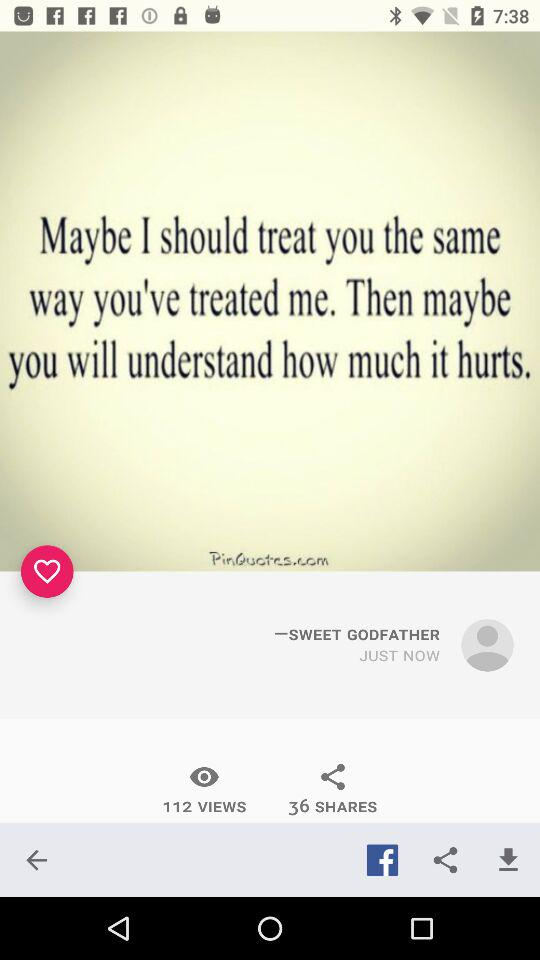How many more views does the post have than shares?
Answer the question using a single word or phrase. 76 